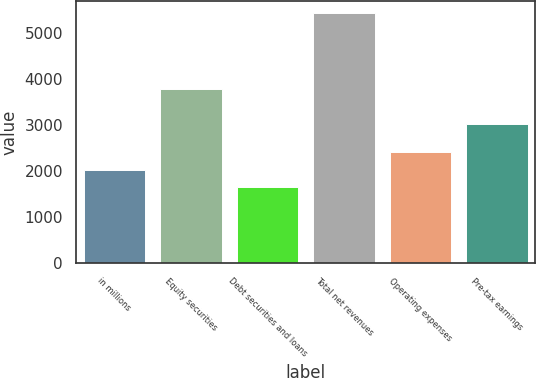<chart> <loc_0><loc_0><loc_500><loc_500><bar_chart><fcel>in millions<fcel>Equity securities<fcel>Debt securities and loans<fcel>Total net revenues<fcel>Operating expenses<fcel>Pre-tax earnings<nl><fcel>2033.1<fcel>3781<fcel>1655<fcel>5436<fcel>2411.2<fcel>3034<nl></chart> 